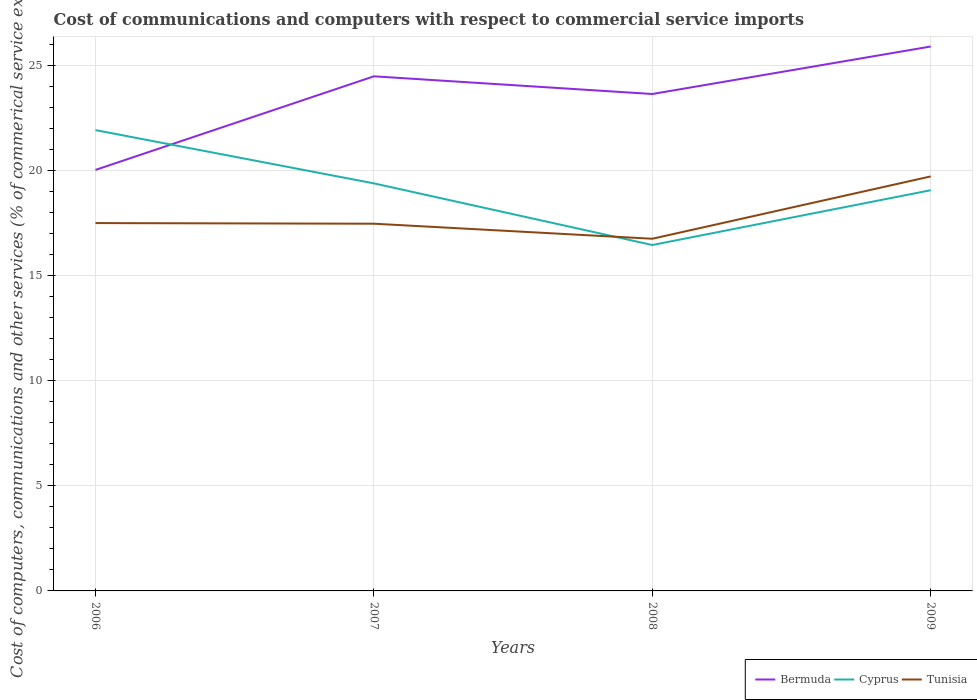How many different coloured lines are there?
Ensure brevity in your answer.  3. Does the line corresponding to Cyprus intersect with the line corresponding to Tunisia?
Offer a terse response. Yes. Is the number of lines equal to the number of legend labels?
Ensure brevity in your answer.  Yes. Across all years, what is the maximum cost of communications and computers in Bermuda?
Offer a terse response. 20.02. What is the total cost of communications and computers in Bermuda in the graph?
Your answer should be very brief. -3.61. What is the difference between the highest and the second highest cost of communications and computers in Bermuda?
Your answer should be compact. 5.87. What is the difference between the highest and the lowest cost of communications and computers in Cyprus?
Offer a very short reply. 2. How many lines are there?
Your response must be concise. 3. What is the difference between two consecutive major ticks on the Y-axis?
Keep it short and to the point. 5. Are the values on the major ticks of Y-axis written in scientific E-notation?
Keep it short and to the point. No. How many legend labels are there?
Provide a short and direct response. 3. How are the legend labels stacked?
Your answer should be compact. Horizontal. What is the title of the graph?
Give a very brief answer. Cost of communications and computers with respect to commercial service imports. Does "St. Martin (French part)" appear as one of the legend labels in the graph?
Keep it short and to the point. No. What is the label or title of the Y-axis?
Your answer should be very brief. Cost of computers, communications and other services (% of commerical service exports). What is the Cost of computers, communications and other services (% of commerical service exports) of Bermuda in 2006?
Keep it short and to the point. 20.02. What is the Cost of computers, communications and other services (% of commerical service exports) in Cyprus in 2006?
Offer a terse response. 21.91. What is the Cost of computers, communications and other services (% of commerical service exports) of Tunisia in 2006?
Your response must be concise. 17.49. What is the Cost of computers, communications and other services (% of commerical service exports) of Bermuda in 2007?
Your answer should be compact. 24.47. What is the Cost of computers, communications and other services (% of commerical service exports) of Cyprus in 2007?
Keep it short and to the point. 19.38. What is the Cost of computers, communications and other services (% of commerical service exports) in Tunisia in 2007?
Ensure brevity in your answer.  17.46. What is the Cost of computers, communications and other services (% of commerical service exports) of Bermuda in 2008?
Give a very brief answer. 23.63. What is the Cost of computers, communications and other services (% of commerical service exports) in Cyprus in 2008?
Provide a short and direct response. 16.45. What is the Cost of computers, communications and other services (% of commerical service exports) in Tunisia in 2008?
Ensure brevity in your answer.  16.75. What is the Cost of computers, communications and other services (% of commerical service exports) in Bermuda in 2009?
Make the answer very short. 25.89. What is the Cost of computers, communications and other services (% of commerical service exports) in Cyprus in 2009?
Keep it short and to the point. 19.05. What is the Cost of computers, communications and other services (% of commerical service exports) of Tunisia in 2009?
Make the answer very short. 19.71. Across all years, what is the maximum Cost of computers, communications and other services (% of commerical service exports) in Bermuda?
Provide a short and direct response. 25.89. Across all years, what is the maximum Cost of computers, communications and other services (% of commerical service exports) of Cyprus?
Provide a short and direct response. 21.91. Across all years, what is the maximum Cost of computers, communications and other services (% of commerical service exports) of Tunisia?
Ensure brevity in your answer.  19.71. Across all years, what is the minimum Cost of computers, communications and other services (% of commerical service exports) in Bermuda?
Your answer should be very brief. 20.02. Across all years, what is the minimum Cost of computers, communications and other services (% of commerical service exports) of Cyprus?
Offer a terse response. 16.45. Across all years, what is the minimum Cost of computers, communications and other services (% of commerical service exports) in Tunisia?
Your answer should be very brief. 16.75. What is the total Cost of computers, communications and other services (% of commerical service exports) in Bermuda in the graph?
Ensure brevity in your answer.  94. What is the total Cost of computers, communications and other services (% of commerical service exports) in Cyprus in the graph?
Your response must be concise. 76.79. What is the total Cost of computers, communications and other services (% of commerical service exports) of Tunisia in the graph?
Provide a short and direct response. 71.41. What is the difference between the Cost of computers, communications and other services (% of commerical service exports) in Bermuda in 2006 and that in 2007?
Ensure brevity in your answer.  -4.45. What is the difference between the Cost of computers, communications and other services (% of commerical service exports) of Cyprus in 2006 and that in 2007?
Your answer should be compact. 2.53. What is the difference between the Cost of computers, communications and other services (% of commerical service exports) of Tunisia in 2006 and that in 2007?
Make the answer very short. 0.03. What is the difference between the Cost of computers, communications and other services (% of commerical service exports) of Bermuda in 2006 and that in 2008?
Offer a very short reply. -3.61. What is the difference between the Cost of computers, communications and other services (% of commerical service exports) in Cyprus in 2006 and that in 2008?
Provide a succinct answer. 5.46. What is the difference between the Cost of computers, communications and other services (% of commerical service exports) in Tunisia in 2006 and that in 2008?
Your response must be concise. 0.74. What is the difference between the Cost of computers, communications and other services (% of commerical service exports) of Bermuda in 2006 and that in 2009?
Your response must be concise. -5.87. What is the difference between the Cost of computers, communications and other services (% of commerical service exports) of Cyprus in 2006 and that in 2009?
Keep it short and to the point. 2.86. What is the difference between the Cost of computers, communications and other services (% of commerical service exports) of Tunisia in 2006 and that in 2009?
Offer a terse response. -2.22. What is the difference between the Cost of computers, communications and other services (% of commerical service exports) of Bermuda in 2007 and that in 2008?
Give a very brief answer. 0.84. What is the difference between the Cost of computers, communications and other services (% of commerical service exports) in Cyprus in 2007 and that in 2008?
Your answer should be very brief. 2.93. What is the difference between the Cost of computers, communications and other services (% of commerical service exports) in Tunisia in 2007 and that in 2008?
Offer a very short reply. 0.71. What is the difference between the Cost of computers, communications and other services (% of commerical service exports) in Bermuda in 2007 and that in 2009?
Keep it short and to the point. -1.42. What is the difference between the Cost of computers, communications and other services (% of commerical service exports) in Cyprus in 2007 and that in 2009?
Make the answer very short. 0.33. What is the difference between the Cost of computers, communications and other services (% of commerical service exports) in Tunisia in 2007 and that in 2009?
Your answer should be very brief. -2.25. What is the difference between the Cost of computers, communications and other services (% of commerical service exports) in Bermuda in 2008 and that in 2009?
Your answer should be compact. -2.26. What is the difference between the Cost of computers, communications and other services (% of commerical service exports) in Cyprus in 2008 and that in 2009?
Your answer should be very brief. -2.61. What is the difference between the Cost of computers, communications and other services (% of commerical service exports) of Tunisia in 2008 and that in 2009?
Ensure brevity in your answer.  -2.96. What is the difference between the Cost of computers, communications and other services (% of commerical service exports) in Bermuda in 2006 and the Cost of computers, communications and other services (% of commerical service exports) in Cyprus in 2007?
Provide a succinct answer. 0.64. What is the difference between the Cost of computers, communications and other services (% of commerical service exports) of Bermuda in 2006 and the Cost of computers, communications and other services (% of commerical service exports) of Tunisia in 2007?
Provide a short and direct response. 2.56. What is the difference between the Cost of computers, communications and other services (% of commerical service exports) of Cyprus in 2006 and the Cost of computers, communications and other services (% of commerical service exports) of Tunisia in 2007?
Offer a terse response. 4.45. What is the difference between the Cost of computers, communications and other services (% of commerical service exports) of Bermuda in 2006 and the Cost of computers, communications and other services (% of commerical service exports) of Cyprus in 2008?
Provide a short and direct response. 3.57. What is the difference between the Cost of computers, communications and other services (% of commerical service exports) in Bermuda in 2006 and the Cost of computers, communications and other services (% of commerical service exports) in Tunisia in 2008?
Provide a short and direct response. 3.27. What is the difference between the Cost of computers, communications and other services (% of commerical service exports) in Cyprus in 2006 and the Cost of computers, communications and other services (% of commerical service exports) in Tunisia in 2008?
Your response must be concise. 5.17. What is the difference between the Cost of computers, communications and other services (% of commerical service exports) of Bermuda in 2006 and the Cost of computers, communications and other services (% of commerical service exports) of Cyprus in 2009?
Your answer should be very brief. 0.97. What is the difference between the Cost of computers, communications and other services (% of commerical service exports) of Bermuda in 2006 and the Cost of computers, communications and other services (% of commerical service exports) of Tunisia in 2009?
Your answer should be compact. 0.31. What is the difference between the Cost of computers, communications and other services (% of commerical service exports) of Cyprus in 2006 and the Cost of computers, communications and other services (% of commerical service exports) of Tunisia in 2009?
Offer a terse response. 2.2. What is the difference between the Cost of computers, communications and other services (% of commerical service exports) of Bermuda in 2007 and the Cost of computers, communications and other services (% of commerical service exports) of Cyprus in 2008?
Make the answer very short. 8.02. What is the difference between the Cost of computers, communications and other services (% of commerical service exports) in Bermuda in 2007 and the Cost of computers, communications and other services (% of commerical service exports) in Tunisia in 2008?
Provide a succinct answer. 7.72. What is the difference between the Cost of computers, communications and other services (% of commerical service exports) of Cyprus in 2007 and the Cost of computers, communications and other services (% of commerical service exports) of Tunisia in 2008?
Ensure brevity in your answer.  2.63. What is the difference between the Cost of computers, communications and other services (% of commerical service exports) in Bermuda in 2007 and the Cost of computers, communications and other services (% of commerical service exports) in Cyprus in 2009?
Your answer should be very brief. 5.42. What is the difference between the Cost of computers, communications and other services (% of commerical service exports) in Bermuda in 2007 and the Cost of computers, communications and other services (% of commerical service exports) in Tunisia in 2009?
Ensure brevity in your answer.  4.76. What is the difference between the Cost of computers, communications and other services (% of commerical service exports) in Cyprus in 2007 and the Cost of computers, communications and other services (% of commerical service exports) in Tunisia in 2009?
Provide a succinct answer. -0.33. What is the difference between the Cost of computers, communications and other services (% of commerical service exports) in Bermuda in 2008 and the Cost of computers, communications and other services (% of commerical service exports) in Cyprus in 2009?
Your answer should be very brief. 4.57. What is the difference between the Cost of computers, communications and other services (% of commerical service exports) of Bermuda in 2008 and the Cost of computers, communications and other services (% of commerical service exports) of Tunisia in 2009?
Provide a short and direct response. 3.92. What is the difference between the Cost of computers, communications and other services (% of commerical service exports) in Cyprus in 2008 and the Cost of computers, communications and other services (% of commerical service exports) in Tunisia in 2009?
Give a very brief answer. -3.26. What is the average Cost of computers, communications and other services (% of commerical service exports) of Bermuda per year?
Offer a very short reply. 23.5. What is the average Cost of computers, communications and other services (% of commerical service exports) of Cyprus per year?
Make the answer very short. 19.2. What is the average Cost of computers, communications and other services (% of commerical service exports) of Tunisia per year?
Offer a very short reply. 17.85. In the year 2006, what is the difference between the Cost of computers, communications and other services (% of commerical service exports) of Bermuda and Cost of computers, communications and other services (% of commerical service exports) of Cyprus?
Provide a succinct answer. -1.89. In the year 2006, what is the difference between the Cost of computers, communications and other services (% of commerical service exports) of Bermuda and Cost of computers, communications and other services (% of commerical service exports) of Tunisia?
Provide a short and direct response. 2.53. In the year 2006, what is the difference between the Cost of computers, communications and other services (% of commerical service exports) in Cyprus and Cost of computers, communications and other services (% of commerical service exports) in Tunisia?
Your answer should be very brief. 4.42. In the year 2007, what is the difference between the Cost of computers, communications and other services (% of commerical service exports) of Bermuda and Cost of computers, communications and other services (% of commerical service exports) of Cyprus?
Offer a very short reply. 5.09. In the year 2007, what is the difference between the Cost of computers, communications and other services (% of commerical service exports) in Bermuda and Cost of computers, communications and other services (% of commerical service exports) in Tunisia?
Offer a very short reply. 7.01. In the year 2007, what is the difference between the Cost of computers, communications and other services (% of commerical service exports) of Cyprus and Cost of computers, communications and other services (% of commerical service exports) of Tunisia?
Offer a terse response. 1.92. In the year 2008, what is the difference between the Cost of computers, communications and other services (% of commerical service exports) of Bermuda and Cost of computers, communications and other services (% of commerical service exports) of Cyprus?
Your answer should be compact. 7.18. In the year 2008, what is the difference between the Cost of computers, communications and other services (% of commerical service exports) of Bermuda and Cost of computers, communications and other services (% of commerical service exports) of Tunisia?
Your answer should be compact. 6.88. In the year 2008, what is the difference between the Cost of computers, communications and other services (% of commerical service exports) in Cyprus and Cost of computers, communications and other services (% of commerical service exports) in Tunisia?
Offer a terse response. -0.3. In the year 2009, what is the difference between the Cost of computers, communications and other services (% of commerical service exports) in Bermuda and Cost of computers, communications and other services (% of commerical service exports) in Cyprus?
Make the answer very short. 6.83. In the year 2009, what is the difference between the Cost of computers, communications and other services (% of commerical service exports) in Bermuda and Cost of computers, communications and other services (% of commerical service exports) in Tunisia?
Provide a succinct answer. 6.18. In the year 2009, what is the difference between the Cost of computers, communications and other services (% of commerical service exports) in Cyprus and Cost of computers, communications and other services (% of commerical service exports) in Tunisia?
Provide a succinct answer. -0.66. What is the ratio of the Cost of computers, communications and other services (% of commerical service exports) of Bermuda in 2006 to that in 2007?
Make the answer very short. 0.82. What is the ratio of the Cost of computers, communications and other services (% of commerical service exports) of Cyprus in 2006 to that in 2007?
Keep it short and to the point. 1.13. What is the ratio of the Cost of computers, communications and other services (% of commerical service exports) in Bermuda in 2006 to that in 2008?
Your answer should be very brief. 0.85. What is the ratio of the Cost of computers, communications and other services (% of commerical service exports) in Cyprus in 2006 to that in 2008?
Offer a very short reply. 1.33. What is the ratio of the Cost of computers, communications and other services (% of commerical service exports) in Tunisia in 2006 to that in 2008?
Provide a short and direct response. 1.04. What is the ratio of the Cost of computers, communications and other services (% of commerical service exports) in Bermuda in 2006 to that in 2009?
Make the answer very short. 0.77. What is the ratio of the Cost of computers, communications and other services (% of commerical service exports) in Cyprus in 2006 to that in 2009?
Provide a short and direct response. 1.15. What is the ratio of the Cost of computers, communications and other services (% of commerical service exports) of Tunisia in 2006 to that in 2009?
Provide a succinct answer. 0.89. What is the ratio of the Cost of computers, communications and other services (% of commerical service exports) of Bermuda in 2007 to that in 2008?
Keep it short and to the point. 1.04. What is the ratio of the Cost of computers, communications and other services (% of commerical service exports) of Cyprus in 2007 to that in 2008?
Your answer should be very brief. 1.18. What is the ratio of the Cost of computers, communications and other services (% of commerical service exports) in Tunisia in 2007 to that in 2008?
Your answer should be compact. 1.04. What is the ratio of the Cost of computers, communications and other services (% of commerical service exports) in Bermuda in 2007 to that in 2009?
Provide a succinct answer. 0.95. What is the ratio of the Cost of computers, communications and other services (% of commerical service exports) in Cyprus in 2007 to that in 2009?
Your response must be concise. 1.02. What is the ratio of the Cost of computers, communications and other services (% of commerical service exports) of Tunisia in 2007 to that in 2009?
Your answer should be compact. 0.89. What is the ratio of the Cost of computers, communications and other services (% of commerical service exports) of Bermuda in 2008 to that in 2009?
Offer a terse response. 0.91. What is the ratio of the Cost of computers, communications and other services (% of commerical service exports) in Cyprus in 2008 to that in 2009?
Your answer should be very brief. 0.86. What is the ratio of the Cost of computers, communications and other services (% of commerical service exports) in Tunisia in 2008 to that in 2009?
Provide a short and direct response. 0.85. What is the difference between the highest and the second highest Cost of computers, communications and other services (% of commerical service exports) of Bermuda?
Offer a terse response. 1.42. What is the difference between the highest and the second highest Cost of computers, communications and other services (% of commerical service exports) in Cyprus?
Keep it short and to the point. 2.53. What is the difference between the highest and the second highest Cost of computers, communications and other services (% of commerical service exports) in Tunisia?
Keep it short and to the point. 2.22. What is the difference between the highest and the lowest Cost of computers, communications and other services (% of commerical service exports) in Bermuda?
Keep it short and to the point. 5.87. What is the difference between the highest and the lowest Cost of computers, communications and other services (% of commerical service exports) of Cyprus?
Offer a terse response. 5.46. What is the difference between the highest and the lowest Cost of computers, communications and other services (% of commerical service exports) in Tunisia?
Provide a short and direct response. 2.96. 